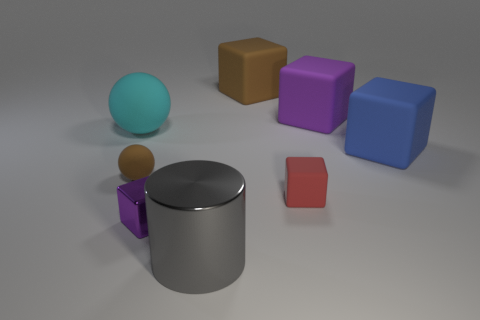Subtract 1 cubes. How many cubes are left? 4 Subtract all large purple rubber cubes. How many cubes are left? 4 Subtract all yellow cubes. Subtract all green cylinders. How many cubes are left? 5 Add 2 gray matte spheres. How many objects exist? 10 Subtract all spheres. How many objects are left? 6 Subtract 1 red cubes. How many objects are left? 7 Subtract all tiny yellow metallic balls. Subtract all gray shiny objects. How many objects are left? 7 Add 4 blue cubes. How many blue cubes are left? 5 Add 5 shiny blocks. How many shiny blocks exist? 6 